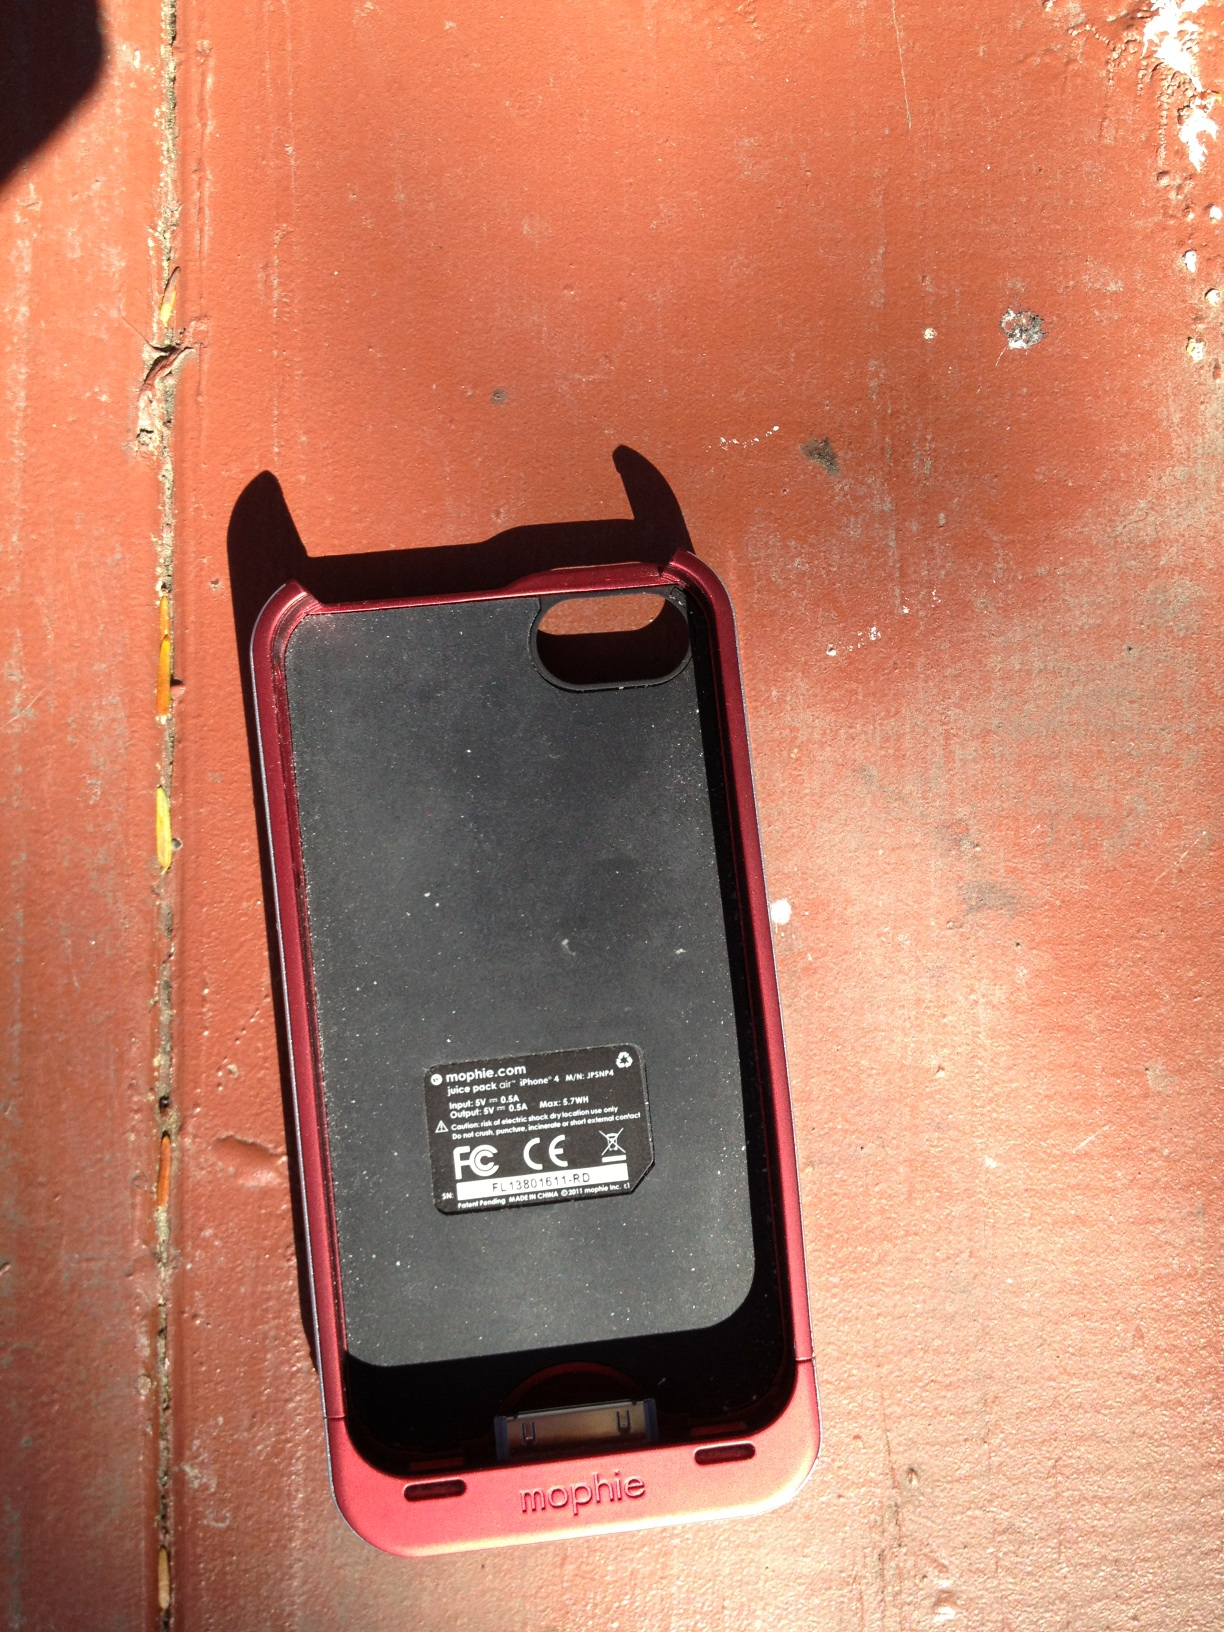What should be kept in mind when using this type of battery pack case? Users should ensure the device is charged regularly and kept at optimal temperatures to prevent overheating. Also, it's important to verify the case's compatibility with your specific smartphone model to ensure efficient operation. 